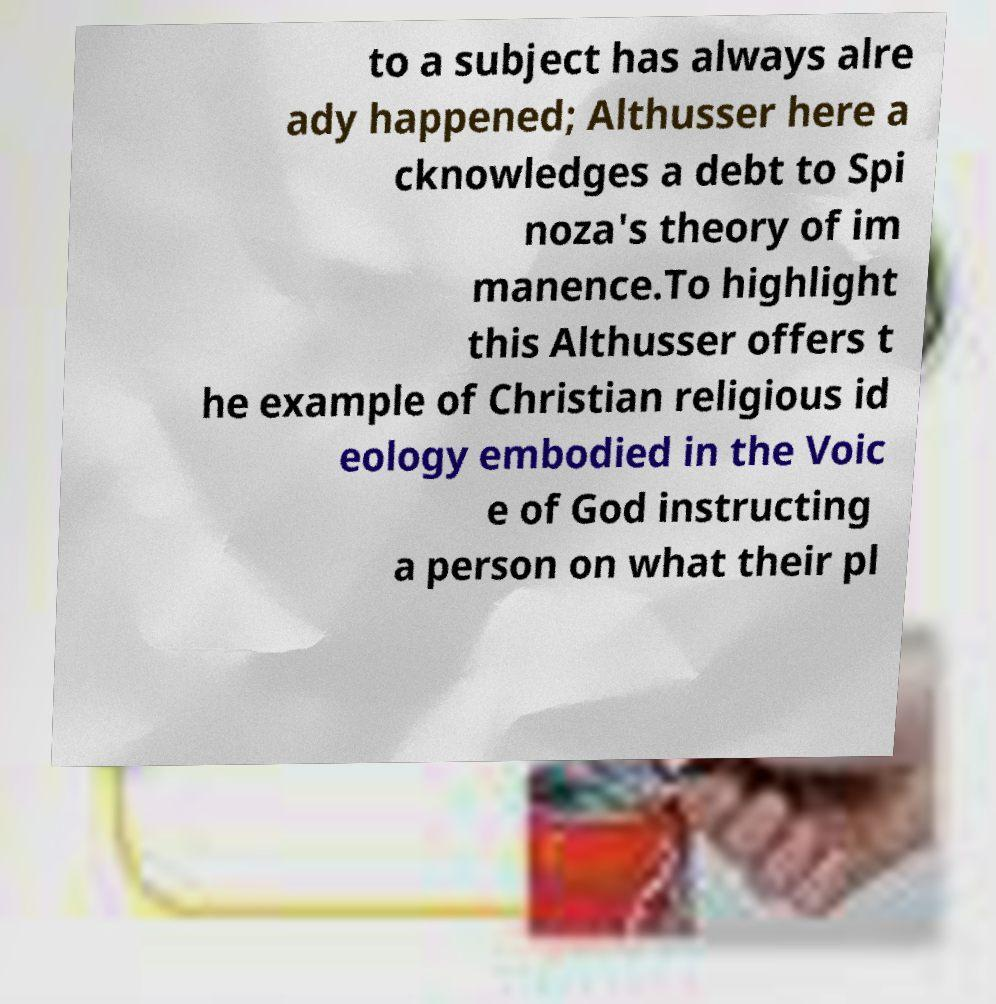For documentation purposes, I need the text within this image transcribed. Could you provide that? to a subject has always alre ady happened; Althusser here a cknowledges a debt to Spi noza's theory of im manence.To highlight this Althusser offers t he example of Christian religious id eology embodied in the Voic e of God instructing a person on what their pl 